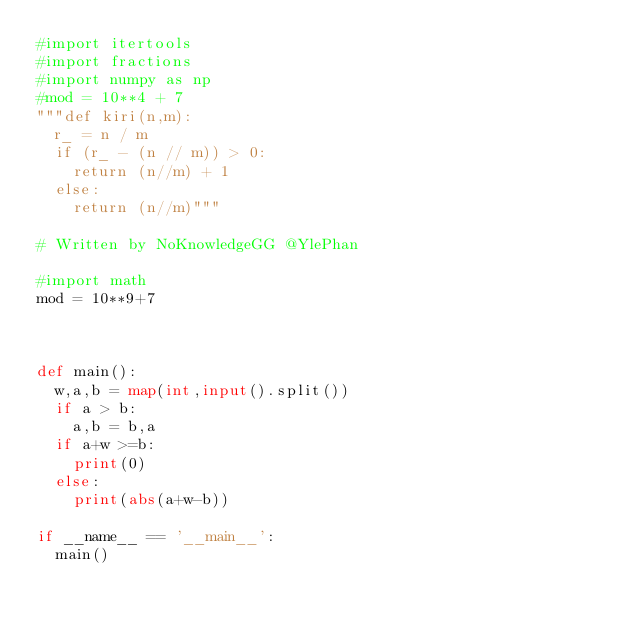<code> <loc_0><loc_0><loc_500><loc_500><_Python_>#import itertools
#import fractions
#import numpy as np
#mod = 10**4 + 7
"""def kiri(n,m):
  r_ = n / m
  if (r_ - (n // m)) > 0:
    return (n//m) + 1
  else:
    return (n//m)"""

# Written by NoKnowledgeGG @YlePhan

#import math
mod = 10**9+7



def main():
  w,a,b = map(int,input().split())
  if a > b:
    a,b = b,a
  if a+w >=b:
    print(0)
  else:
    print(abs(a+w-b))
  
if __name__ == '__main__':
  main()</code> 